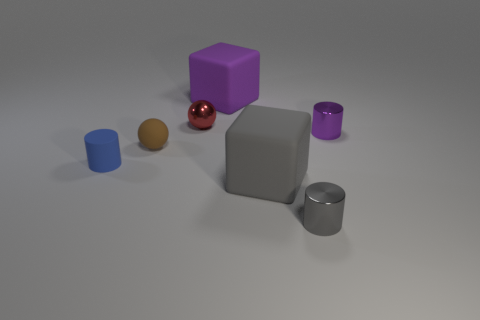Does the big rubber thing that is in front of the brown thing have the same color as the small metal cylinder in front of the brown rubber ball?
Offer a terse response. Yes. What is the color of the object that is both to the right of the large purple block and on the left side of the gray shiny object?
Ensure brevity in your answer.  Gray. What is the color of the thing on the right side of the small gray metal cylinder that is in front of the large rubber cube that is in front of the blue matte object?
Make the answer very short. Purple. The rubber cylinder that is the same size as the red metal ball is what color?
Offer a terse response. Blue. There is a small shiny thing left of the cylinder in front of the matte cube that is on the right side of the purple matte object; what is its shape?
Offer a terse response. Sphere. What number of things are small blue things or tiny purple objects that are right of the gray matte thing?
Make the answer very short. 2. Is the size of the blue matte cylinder in front of the purple block the same as the gray rubber object?
Keep it short and to the point. No. What material is the small cylinder behind the tiny blue matte thing?
Keep it short and to the point. Metal. Is the number of purple cylinders that are right of the small purple cylinder the same as the number of tiny cylinders behind the gray metal cylinder?
Keep it short and to the point. No. What is the color of the other object that is the same shape as the large gray object?
Offer a very short reply. Purple. 